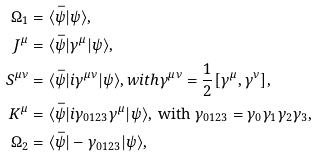<formula> <loc_0><loc_0><loc_500><loc_500>\Omega _ { 1 } & = \langle \bar { \psi } | \psi \rangle , \\ J ^ { \mu } & = \langle \bar { \psi } | \gamma ^ { \mu } | \psi \rangle , \\ S ^ { \mu \nu } & = \langle \bar { \psi } | i \gamma ^ { \mu \nu } | \psi \rangle , w i t h \gamma ^ { \mu \nu } = \frac { 1 } { 2 } [ \gamma ^ { \mu } , \gamma ^ { \nu } ] , \\ K ^ { \mu } & = \langle \bar { \psi } | i \gamma _ { 0 1 2 3 } \gamma ^ { \mu } | \psi \rangle , \text { with } \gamma _ { 0 1 2 3 } = \gamma _ { 0 } \gamma _ { 1 } \gamma _ { 2 } \gamma _ { 3 } , \\ \Omega _ { 2 } & = \langle \bar { \psi } | - \gamma _ { 0 1 2 3 } | \psi \rangle ,</formula> 